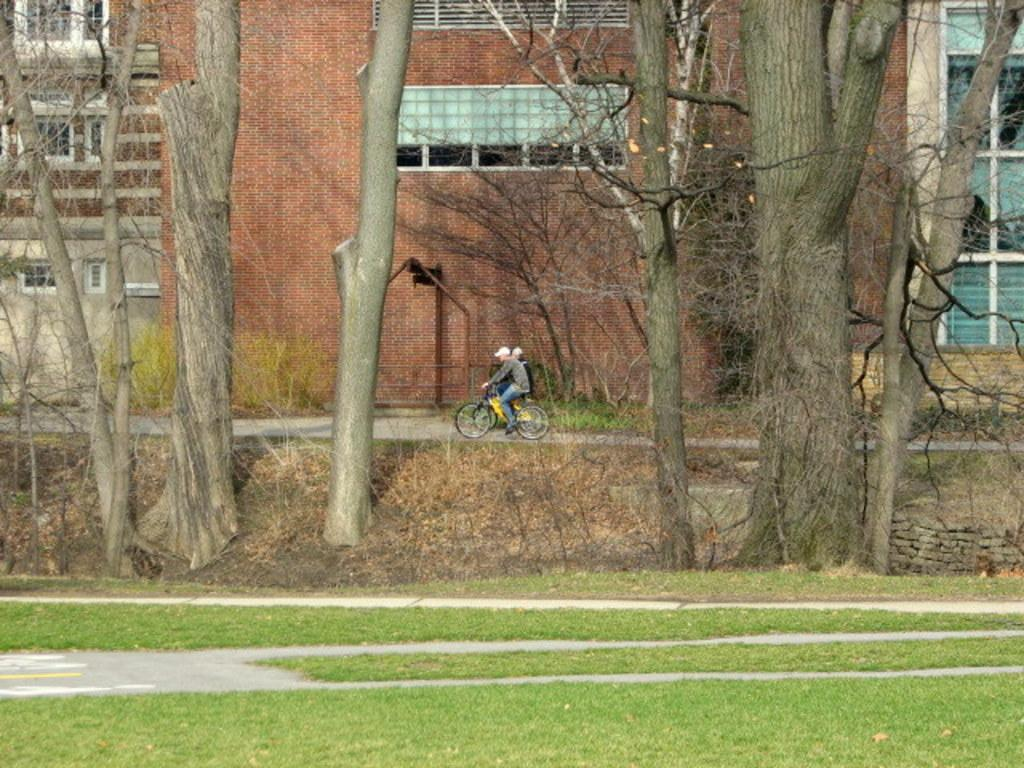What type of vegetation is present in the image? There is grass in the image. What other natural elements can be seen in the image? There are trees in the image. How many people are in the image, and what are they doing? There are two people in the image, and they are sitting and riding bicycles. What can be seen in the background of the image? There is a building and a wall in the background of the image. How many grapes are being used in the operation depicted in the image? There are no grapes or operations present in the image; it features people sitting and riding bicycles in a natural setting. 